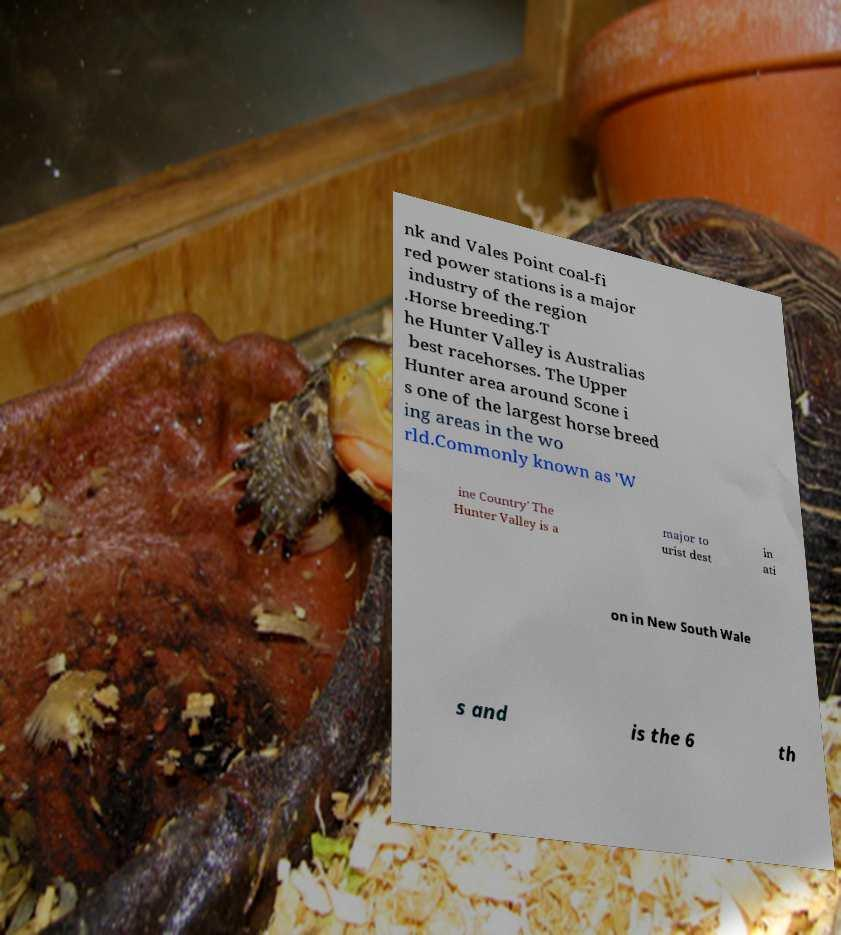Can you accurately transcribe the text from the provided image for me? nk and Vales Point coal-fi red power stations is a major industry of the region .Horse breeding.T he Hunter Valley is Australias best racehorses. The Upper Hunter area around Scone i s one of the largest horse breed ing areas in the wo rld.Commonly known as 'W ine Country' The Hunter Valley is a major to urist dest in ati on in New South Wale s and is the 6 th 